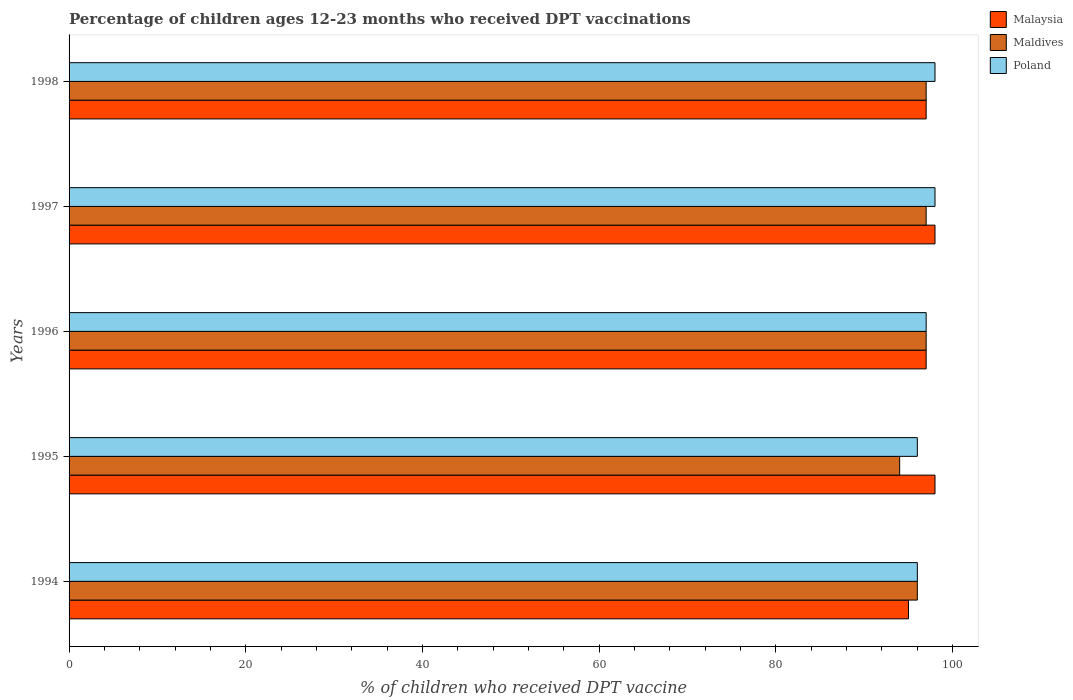How many groups of bars are there?
Give a very brief answer. 5. Are the number of bars per tick equal to the number of legend labels?
Provide a succinct answer. Yes. How many bars are there on the 1st tick from the bottom?
Give a very brief answer. 3. What is the label of the 3rd group of bars from the top?
Your response must be concise. 1996. What is the percentage of children who received DPT vaccination in Maldives in 1997?
Provide a short and direct response. 97. Across all years, what is the maximum percentage of children who received DPT vaccination in Malaysia?
Your response must be concise. 98. Across all years, what is the minimum percentage of children who received DPT vaccination in Malaysia?
Provide a succinct answer. 95. In which year was the percentage of children who received DPT vaccination in Maldives maximum?
Offer a very short reply. 1996. In which year was the percentage of children who received DPT vaccination in Malaysia minimum?
Offer a very short reply. 1994. What is the total percentage of children who received DPT vaccination in Malaysia in the graph?
Offer a very short reply. 485. What is the difference between the percentage of children who received DPT vaccination in Maldives in 1994 and that in 1998?
Give a very brief answer. -1. What is the difference between the percentage of children who received DPT vaccination in Malaysia in 1994 and the percentage of children who received DPT vaccination in Maldives in 1998?
Your answer should be compact. -2. What is the average percentage of children who received DPT vaccination in Malaysia per year?
Keep it short and to the point. 97. What is the difference between the highest and the lowest percentage of children who received DPT vaccination in Poland?
Provide a short and direct response. 2. In how many years, is the percentage of children who received DPT vaccination in Malaysia greater than the average percentage of children who received DPT vaccination in Malaysia taken over all years?
Your answer should be compact. 2. Is the sum of the percentage of children who received DPT vaccination in Poland in 1995 and 1997 greater than the maximum percentage of children who received DPT vaccination in Malaysia across all years?
Offer a terse response. Yes. What does the 2nd bar from the top in 1996 represents?
Give a very brief answer. Maldives. What does the 3rd bar from the bottom in 1994 represents?
Ensure brevity in your answer.  Poland. Is it the case that in every year, the sum of the percentage of children who received DPT vaccination in Maldives and percentage of children who received DPT vaccination in Malaysia is greater than the percentage of children who received DPT vaccination in Poland?
Provide a short and direct response. Yes. Are all the bars in the graph horizontal?
Provide a succinct answer. Yes. Are the values on the major ticks of X-axis written in scientific E-notation?
Offer a very short reply. No. Does the graph contain any zero values?
Provide a short and direct response. No. How are the legend labels stacked?
Keep it short and to the point. Vertical. What is the title of the graph?
Offer a very short reply. Percentage of children ages 12-23 months who received DPT vaccinations. Does "Ireland" appear as one of the legend labels in the graph?
Your response must be concise. No. What is the label or title of the X-axis?
Give a very brief answer. % of children who received DPT vaccine. What is the label or title of the Y-axis?
Ensure brevity in your answer.  Years. What is the % of children who received DPT vaccine in Maldives in 1994?
Keep it short and to the point. 96. What is the % of children who received DPT vaccine in Poland in 1994?
Provide a short and direct response. 96. What is the % of children who received DPT vaccine in Malaysia in 1995?
Give a very brief answer. 98. What is the % of children who received DPT vaccine in Maldives in 1995?
Ensure brevity in your answer.  94. What is the % of children who received DPT vaccine of Poland in 1995?
Your answer should be very brief. 96. What is the % of children who received DPT vaccine of Malaysia in 1996?
Offer a very short reply. 97. What is the % of children who received DPT vaccine in Maldives in 1996?
Give a very brief answer. 97. What is the % of children who received DPT vaccine in Poland in 1996?
Keep it short and to the point. 97. What is the % of children who received DPT vaccine in Maldives in 1997?
Your answer should be compact. 97. What is the % of children who received DPT vaccine in Poland in 1997?
Your response must be concise. 98. What is the % of children who received DPT vaccine of Malaysia in 1998?
Your response must be concise. 97. What is the % of children who received DPT vaccine of Maldives in 1998?
Your response must be concise. 97. What is the % of children who received DPT vaccine of Poland in 1998?
Your answer should be compact. 98. Across all years, what is the maximum % of children who received DPT vaccine in Malaysia?
Make the answer very short. 98. Across all years, what is the maximum % of children who received DPT vaccine in Maldives?
Give a very brief answer. 97. Across all years, what is the minimum % of children who received DPT vaccine in Malaysia?
Provide a short and direct response. 95. Across all years, what is the minimum % of children who received DPT vaccine in Maldives?
Provide a short and direct response. 94. Across all years, what is the minimum % of children who received DPT vaccine of Poland?
Provide a succinct answer. 96. What is the total % of children who received DPT vaccine in Malaysia in the graph?
Offer a very short reply. 485. What is the total % of children who received DPT vaccine in Maldives in the graph?
Offer a very short reply. 481. What is the total % of children who received DPT vaccine of Poland in the graph?
Your answer should be compact. 485. What is the difference between the % of children who received DPT vaccine of Maldives in 1994 and that in 1995?
Give a very brief answer. 2. What is the difference between the % of children who received DPT vaccine in Poland in 1994 and that in 1995?
Your response must be concise. 0. What is the difference between the % of children who received DPT vaccine of Maldives in 1994 and that in 1996?
Ensure brevity in your answer.  -1. What is the difference between the % of children who received DPT vaccine of Poland in 1994 and that in 1996?
Provide a short and direct response. -1. What is the difference between the % of children who received DPT vaccine of Malaysia in 1994 and that in 1997?
Ensure brevity in your answer.  -3. What is the difference between the % of children who received DPT vaccine in Malaysia in 1994 and that in 1998?
Keep it short and to the point. -2. What is the difference between the % of children who received DPT vaccine of Poland in 1994 and that in 1998?
Your response must be concise. -2. What is the difference between the % of children who received DPT vaccine in Poland in 1995 and that in 1996?
Your answer should be compact. -1. What is the difference between the % of children who received DPT vaccine in Maldives in 1995 and that in 1997?
Make the answer very short. -3. What is the difference between the % of children who received DPT vaccine in Maldives in 1995 and that in 1998?
Give a very brief answer. -3. What is the difference between the % of children who received DPT vaccine in Maldives in 1996 and that in 1997?
Ensure brevity in your answer.  0. What is the difference between the % of children who received DPT vaccine in Poland in 1996 and that in 1997?
Provide a succinct answer. -1. What is the difference between the % of children who received DPT vaccine of Malaysia in 1996 and that in 1998?
Provide a short and direct response. 0. What is the difference between the % of children who received DPT vaccine of Maldives in 1996 and that in 1998?
Provide a short and direct response. 0. What is the difference between the % of children who received DPT vaccine of Malaysia in 1997 and that in 1998?
Your answer should be compact. 1. What is the difference between the % of children who received DPT vaccine in Maldives in 1997 and that in 1998?
Your response must be concise. 0. What is the difference between the % of children who received DPT vaccine in Malaysia in 1994 and the % of children who received DPT vaccine in Maldives in 1995?
Your response must be concise. 1. What is the difference between the % of children who received DPT vaccine of Malaysia in 1994 and the % of children who received DPT vaccine of Poland in 1995?
Offer a very short reply. -1. What is the difference between the % of children who received DPT vaccine of Maldives in 1994 and the % of children who received DPT vaccine of Poland in 1995?
Keep it short and to the point. 0. What is the difference between the % of children who received DPT vaccine of Malaysia in 1994 and the % of children who received DPT vaccine of Maldives in 1996?
Offer a very short reply. -2. What is the difference between the % of children who received DPT vaccine of Malaysia in 1994 and the % of children who received DPT vaccine of Poland in 1997?
Keep it short and to the point. -3. What is the difference between the % of children who received DPT vaccine of Maldives in 1994 and the % of children who received DPT vaccine of Poland in 1997?
Your answer should be compact. -2. What is the difference between the % of children who received DPT vaccine in Maldives in 1994 and the % of children who received DPT vaccine in Poland in 1998?
Ensure brevity in your answer.  -2. What is the difference between the % of children who received DPT vaccine in Malaysia in 1995 and the % of children who received DPT vaccine in Poland in 1996?
Make the answer very short. 1. What is the difference between the % of children who received DPT vaccine of Malaysia in 1995 and the % of children who received DPT vaccine of Maldives in 1997?
Your answer should be compact. 1. What is the difference between the % of children who received DPT vaccine in Malaysia in 1995 and the % of children who received DPT vaccine in Poland in 1997?
Your response must be concise. 0. What is the difference between the % of children who received DPT vaccine in Maldives in 1995 and the % of children who received DPT vaccine in Poland in 1997?
Provide a succinct answer. -4. What is the difference between the % of children who received DPT vaccine in Maldives in 1996 and the % of children who received DPT vaccine in Poland in 1997?
Offer a very short reply. -1. What is the difference between the % of children who received DPT vaccine of Malaysia in 1996 and the % of children who received DPT vaccine of Maldives in 1998?
Ensure brevity in your answer.  0. What is the difference between the % of children who received DPT vaccine in Malaysia in 1996 and the % of children who received DPT vaccine in Poland in 1998?
Your answer should be compact. -1. What is the average % of children who received DPT vaccine of Malaysia per year?
Make the answer very short. 97. What is the average % of children who received DPT vaccine in Maldives per year?
Make the answer very short. 96.2. What is the average % of children who received DPT vaccine in Poland per year?
Give a very brief answer. 97. In the year 1994, what is the difference between the % of children who received DPT vaccine of Maldives and % of children who received DPT vaccine of Poland?
Your response must be concise. 0. In the year 1995, what is the difference between the % of children who received DPT vaccine of Maldives and % of children who received DPT vaccine of Poland?
Offer a terse response. -2. In the year 1997, what is the difference between the % of children who received DPT vaccine in Malaysia and % of children who received DPT vaccine in Maldives?
Your response must be concise. 1. In the year 1997, what is the difference between the % of children who received DPT vaccine of Malaysia and % of children who received DPT vaccine of Poland?
Provide a succinct answer. 0. In the year 1997, what is the difference between the % of children who received DPT vaccine in Maldives and % of children who received DPT vaccine in Poland?
Your answer should be very brief. -1. In the year 1998, what is the difference between the % of children who received DPT vaccine in Malaysia and % of children who received DPT vaccine in Maldives?
Your answer should be compact. 0. In the year 1998, what is the difference between the % of children who received DPT vaccine in Malaysia and % of children who received DPT vaccine in Poland?
Make the answer very short. -1. In the year 1998, what is the difference between the % of children who received DPT vaccine in Maldives and % of children who received DPT vaccine in Poland?
Provide a succinct answer. -1. What is the ratio of the % of children who received DPT vaccine of Malaysia in 1994 to that in 1995?
Offer a terse response. 0.97. What is the ratio of the % of children who received DPT vaccine of Maldives in 1994 to that in 1995?
Your answer should be very brief. 1.02. What is the ratio of the % of children who received DPT vaccine of Poland in 1994 to that in 1995?
Offer a terse response. 1. What is the ratio of the % of children who received DPT vaccine in Malaysia in 1994 to that in 1996?
Ensure brevity in your answer.  0.98. What is the ratio of the % of children who received DPT vaccine in Maldives in 1994 to that in 1996?
Provide a succinct answer. 0.99. What is the ratio of the % of children who received DPT vaccine in Poland in 1994 to that in 1996?
Offer a very short reply. 0.99. What is the ratio of the % of children who received DPT vaccine in Malaysia in 1994 to that in 1997?
Provide a short and direct response. 0.97. What is the ratio of the % of children who received DPT vaccine in Maldives in 1994 to that in 1997?
Ensure brevity in your answer.  0.99. What is the ratio of the % of children who received DPT vaccine of Poland in 1994 to that in 1997?
Offer a very short reply. 0.98. What is the ratio of the % of children who received DPT vaccine in Malaysia in 1994 to that in 1998?
Offer a terse response. 0.98. What is the ratio of the % of children who received DPT vaccine of Maldives in 1994 to that in 1998?
Keep it short and to the point. 0.99. What is the ratio of the % of children who received DPT vaccine in Poland in 1994 to that in 1998?
Give a very brief answer. 0.98. What is the ratio of the % of children who received DPT vaccine in Malaysia in 1995 to that in 1996?
Make the answer very short. 1.01. What is the ratio of the % of children who received DPT vaccine of Maldives in 1995 to that in 1996?
Your answer should be compact. 0.97. What is the ratio of the % of children who received DPT vaccine in Maldives in 1995 to that in 1997?
Your answer should be compact. 0.97. What is the ratio of the % of children who received DPT vaccine in Poland in 1995 to that in 1997?
Make the answer very short. 0.98. What is the ratio of the % of children who received DPT vaccine in Malaysia in 1995 to that in 1998?
Your answer should be compact. 1.01. What is the ratio of the % of children who received DPT vaccine in Maldives in 1995 to that in 1998?
Offer a terse response. 0.97. What is the ratio of the % of children who received DPT vaccine in Poland in 1995 to that in 1998?
Provide a succinct answer. 0.98. What is the ratio of the % of children who received DPT vaccine in Maldives in 1996 to that in 1997?
Your answer should be compact. 1. What is the ratio of the % of children who received DPT vaccine in Poland in 1996 to that in 1998?
Your answer should be compact. 0.99. What is the ratio of the % of children who received DPT vaccine in Malaysia in 1997 to that in 1998?
Provide a succinct answer. 1.01. What is the ratio of the % of children who received DPT vaccine of Maldives in 1997 to that in 1998?
Your answer should be very brief. 1. What is the ratio of the % of children who received DPT vaccine in Poland in 1997 to that in 1998?
Provide a succinct answer. 1. What is the difference between the highest and the second highest % of children who received DPT vaccine of Poland?
Ensure brevity in your answer.  0. What is the difference between the highest and the lowest % of children who received DPT vaccine in Malaysia?
Your response must be concise. 3. What is the difference between the highest and the lowest % of children who received DPT vaccine of Maldives?
Give a very brief answer. 3. What is the difference between the highest and the lowest % of children who received DPT vaccine in Poland?
Your answer should be very brief. 2. 